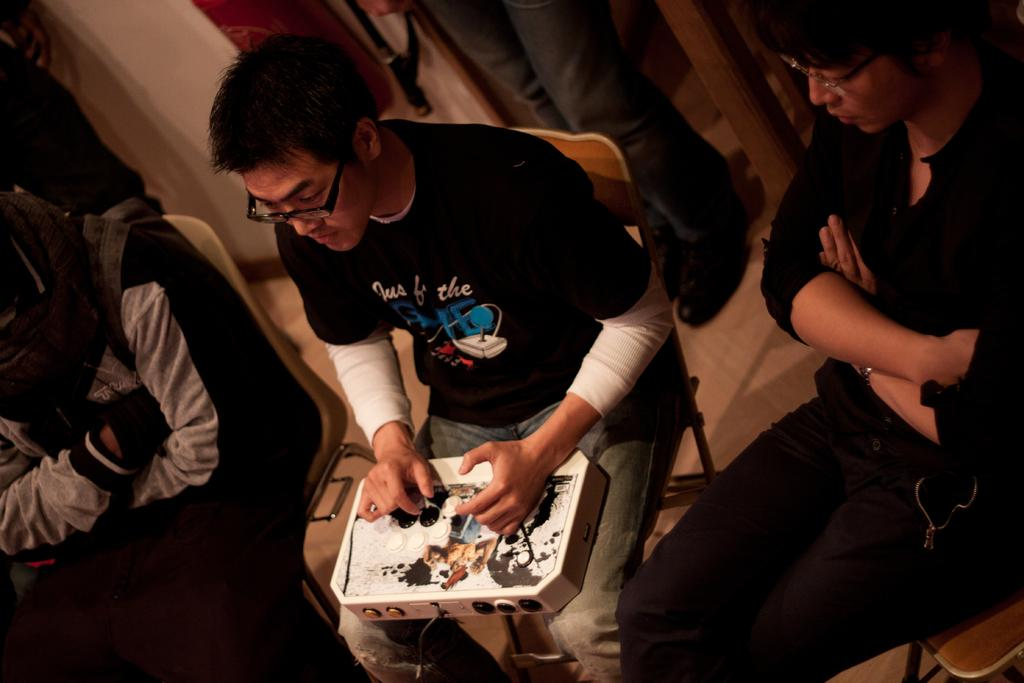What are the people in the image doing? There are people sitting and one person standing in the image. Can you describe the person holding an electric object? The person sitting in the center of the image is holding an electric object in his hands. What type of silver object can be seen in the hands of the creator in the image? There is no creator or silver object present in the image. 